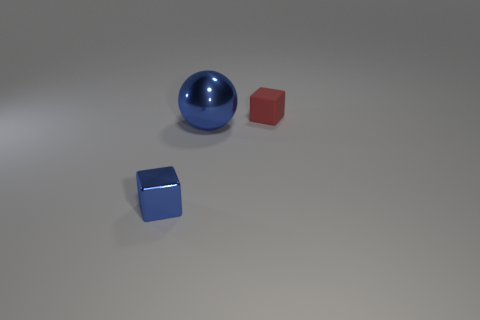Add 1 tiny red metal blocks. How many objects exist? 4 Subtract all balls. How many objects are left? 2 Add 3 blue objects. How many blue objects are left? 5 Add 2 yellow metallic cylinders. How many yellow metallic cylinders exist? 2 Subtract 0 gray spheres. How many objects are left? 3 Subtract all tiny blue things. Subtract all small red things. How many objects are left? 1 